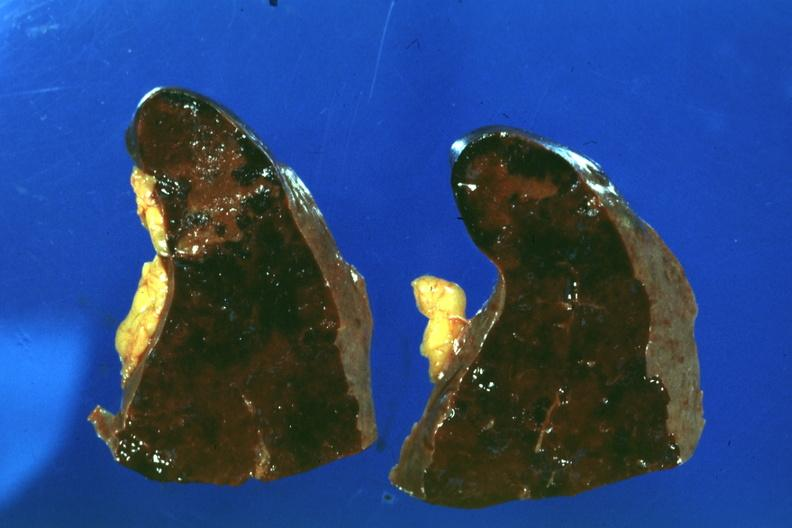does liver show congested spleen infarct easily seen?
Answer the question using a single word or phrase. No 